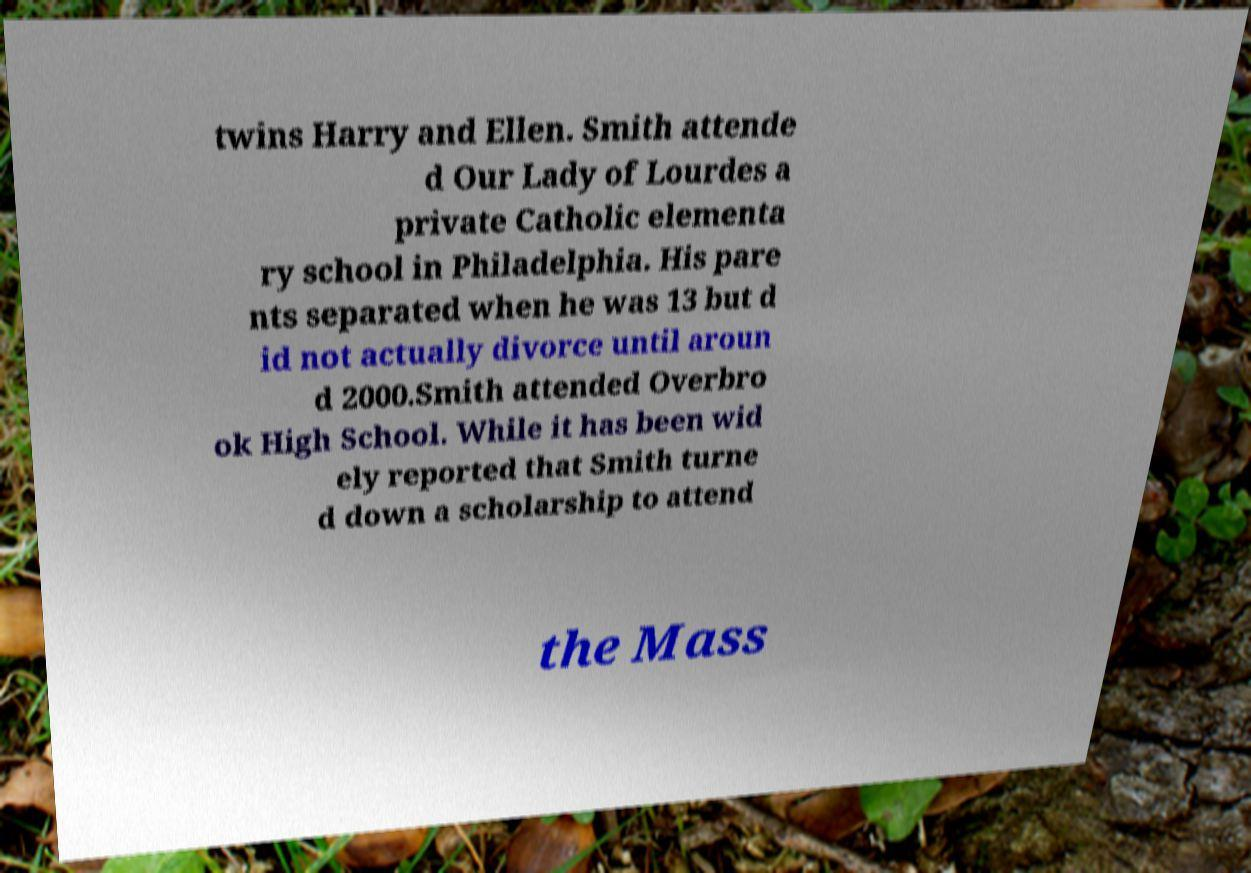Please identify and transcribe the text found in this image. twins Harry and Ellen. Smith attende d Our Lady of Lourdes a private Catholic elementa ry school in Philadelphia. His pare nts separated when he was 13 but d id not actually divorce until aroun d 2000.Smith attended Overbro ok High School. While it has been wid ely reported that Smith turne d down a scholarship to attend the Mass 